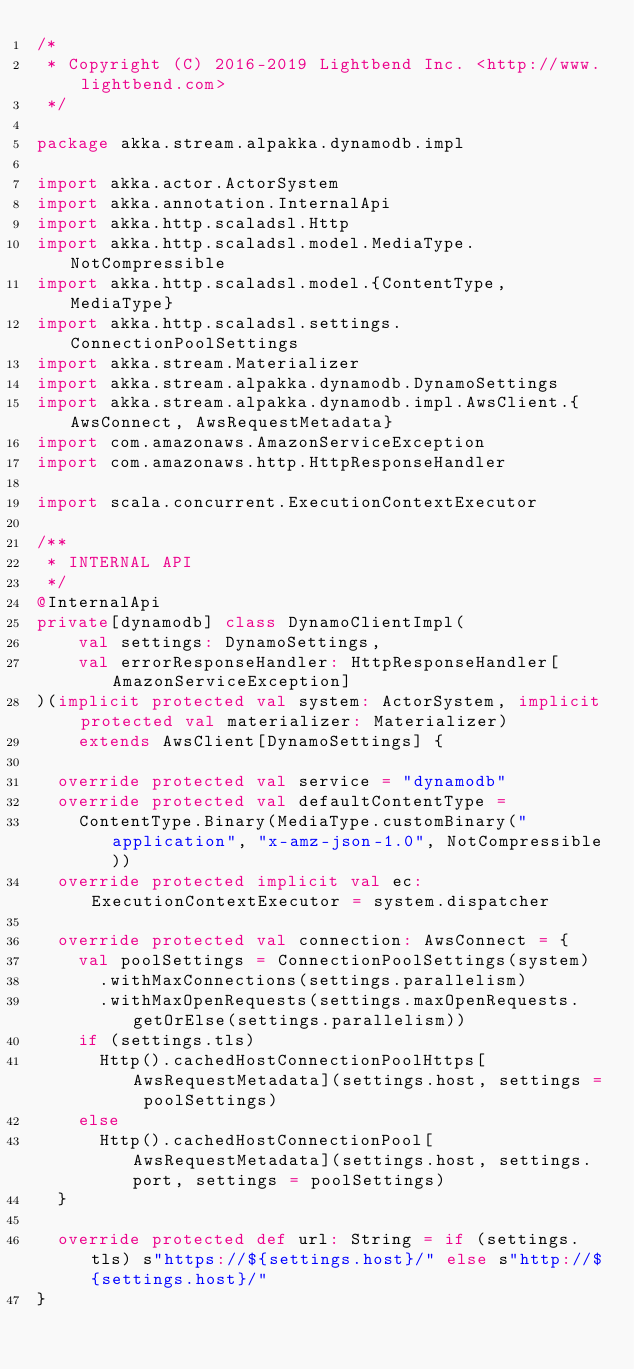Convert code to text. <code><loc_0><loc_0><loc_500><loc_500><_Scala_>/*
 * Copyright (C) 2016-2019 Lightbend Inc. <http://www.lightbend.com>
 */

package akka.stream.alpakka.dynamodb.impl

import akka.actor.ActorSystem
import akka.annotation.InternalApi
import akka.http.scaladsl.Http
import akka.http.scaladsl.model.MediaType.NotCompressible
import akka.http.scaladsl.model.{ContentType, MediaType}
import akka.http.scaladsl.settings.ConnectionPoolSettings
import akka.stream.Materializer
import akka.stream.alpakka.dynamodb.DynamoSettings
import akka.stream.alpakka.dynamodb.impl.AwsClient.{AwsConnect, AwsRequestMetadata}
import com.amazonaws.AmazonServiceException
import com.amazonaws.http.HttpResponseHandler

import scala.concurrent.ExecutionContextExecutor

/**
 * INTERNAL API
 */
@InternalApi
private[dynamodb] class DynamoClientImpl(
    val settings: DynamoSettings,
    val errorResponseHandler: HttpResponseHandler[AmazonServiceException]
)(implicit protected val system: ActorSystem, implicit protected val materializer: Materializer)
    extends AwsClient[DynamoSettings] {

  override protected val service = "dynamodb"
  override protected val defaultContentType =
    ContentType.Binary(MediaType.customBinary("application", "x-amz-json-1.0", NotCompressible))
  override protected implicit val ec: ExecutionContextExecutor = system.dispatcher

  override protected val connection: AwsConnect = {
    val poolSettings = ConnectionPoolSettings(system)
      .withMaxConnections(settings.parallelism)
      .withMaxOpenRequests(settings.maxOpenRequests.getOrElse(settings.parallelism))
    if (settings.tls)
      Http().cachedHostConnectionPoolHttps[AwsRequestMetadata](settings.host, settings = poolSettings)
    else
      Http().cachedHostConnectionPool[AwsRequestMetadata](settings.host, settings.port, settings = poolSettings)
  }

  override protected def url: String = if (settings.tls) s"https://${settings.host}/" else s"http://${settings.host}/"
}
</code> 